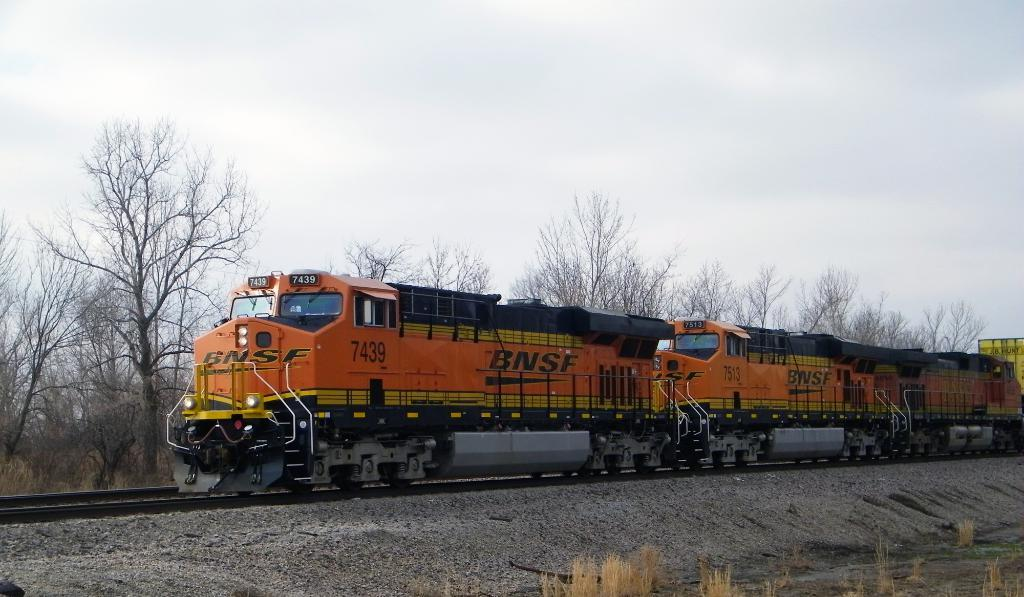What can be seen at the top of the image? The sky is visible towards the top of the image. What type of vegetation is present in the image? There are trees in the image. What is the purpose of the railway track in the image? The railway track is present for the train to travel on. What is the main subject of the image? There is a train in the image. What can be seen at the bottom of the image? There are plants towards the bottom of the image. What credit card company is sponsoring the train in the image? There is no information about a credit card company sponsoring the train in the image. What invention is being used to make the decision about the train's route in the image? There is no mention of a decision-making process or an invention in the image. 